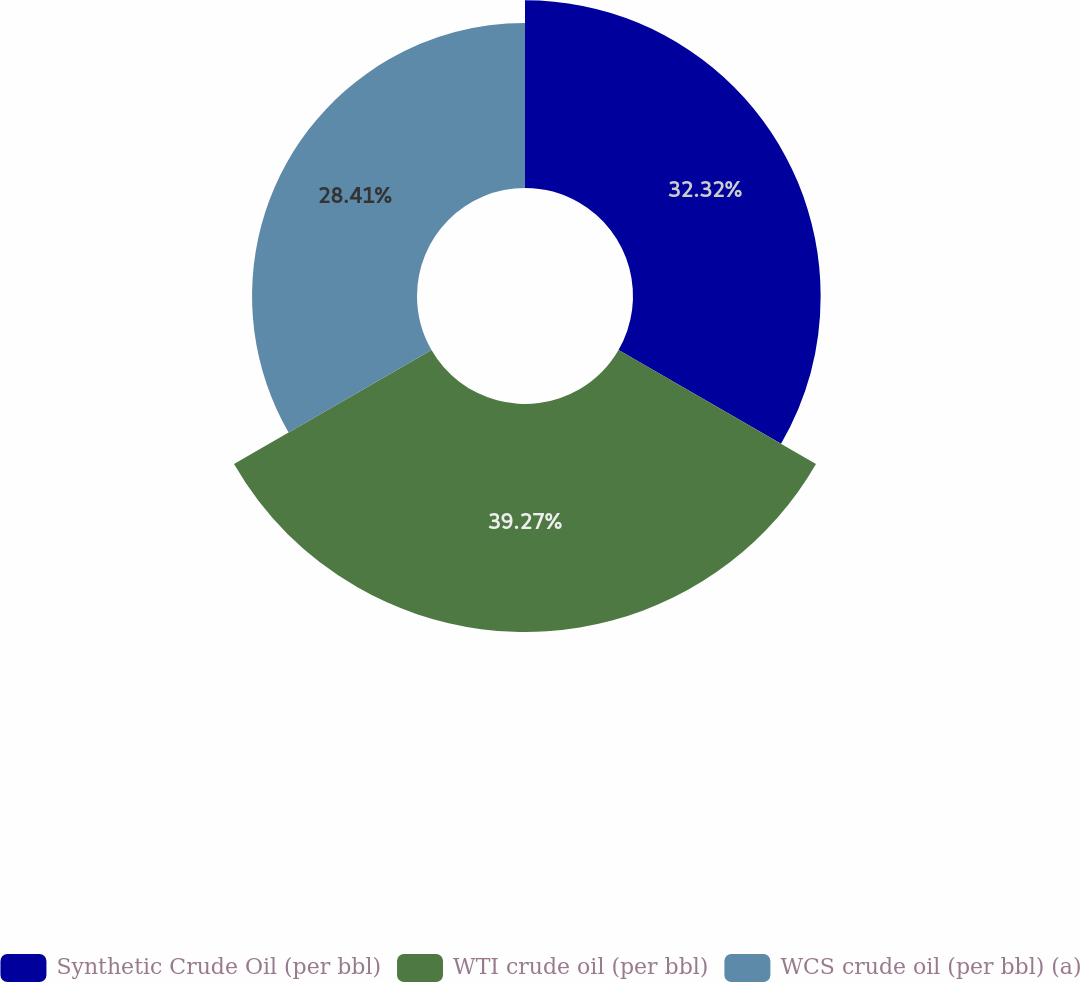<chart> <loc_0><loc_0><loc_500><loc_500><pie_chart><fcel>Synthetic Crude Oil (per bbl)<fcel>WTI crude oil (per bbl)<fcel>WCS crude oil (per bbl) (a)<nl><fcel>32.32%<fcel>39.27%<fcel>28.41%<nl></chart> 